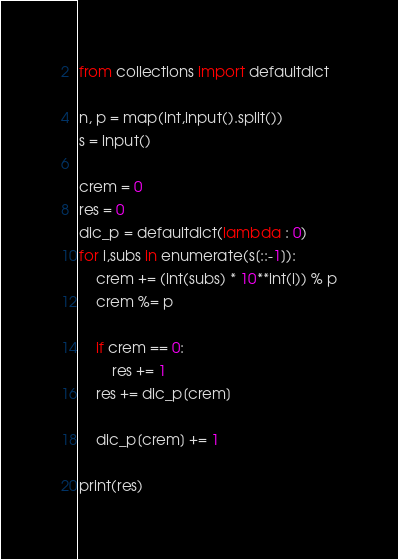Convert code to text. <code><loc_0><loc_0><loc_500><loc_500><_Python_>from collections import defaultdict

n, p = map(int,input().split())
s = input()

crem = 0
res = 0
dic_p = defaultdict(lambda : 0)
for i,subs in enumerate(s[::-1]):
    crem += (int(subs) * 10**int(i)) % p
    crem %= p
    
    if crem == 0:
        res += 1
    res += dic_p[crem]

    dic_p[crem] += 1
    
print(res)</code> 